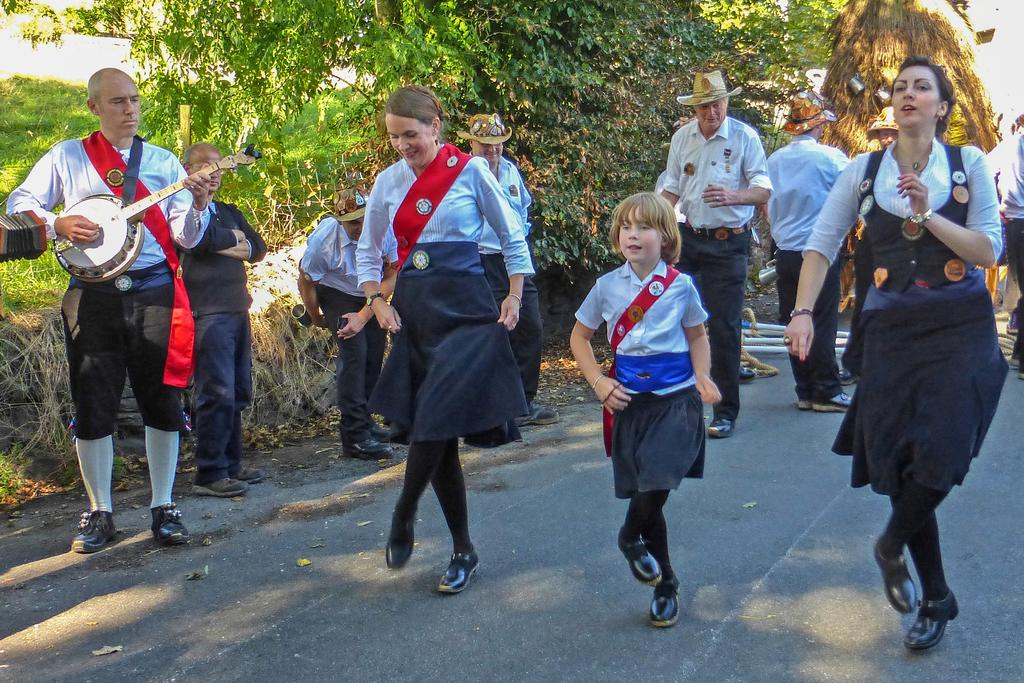What are the people in the image doing? The people in the image are dancing on a road. Can you describe the person on the left side of the image? The person on the left side of the image is playing a musical instrument. What can be seen in the background of the image? There are trees in the background of the image. What type of toothbrush is the person playing the musical instrument using in the image? There is no toothbrush present in the image. What instrument is the person playing in the image? The person is playing a musical instrument, but the specific type of instrument is not mentioned in the image. 